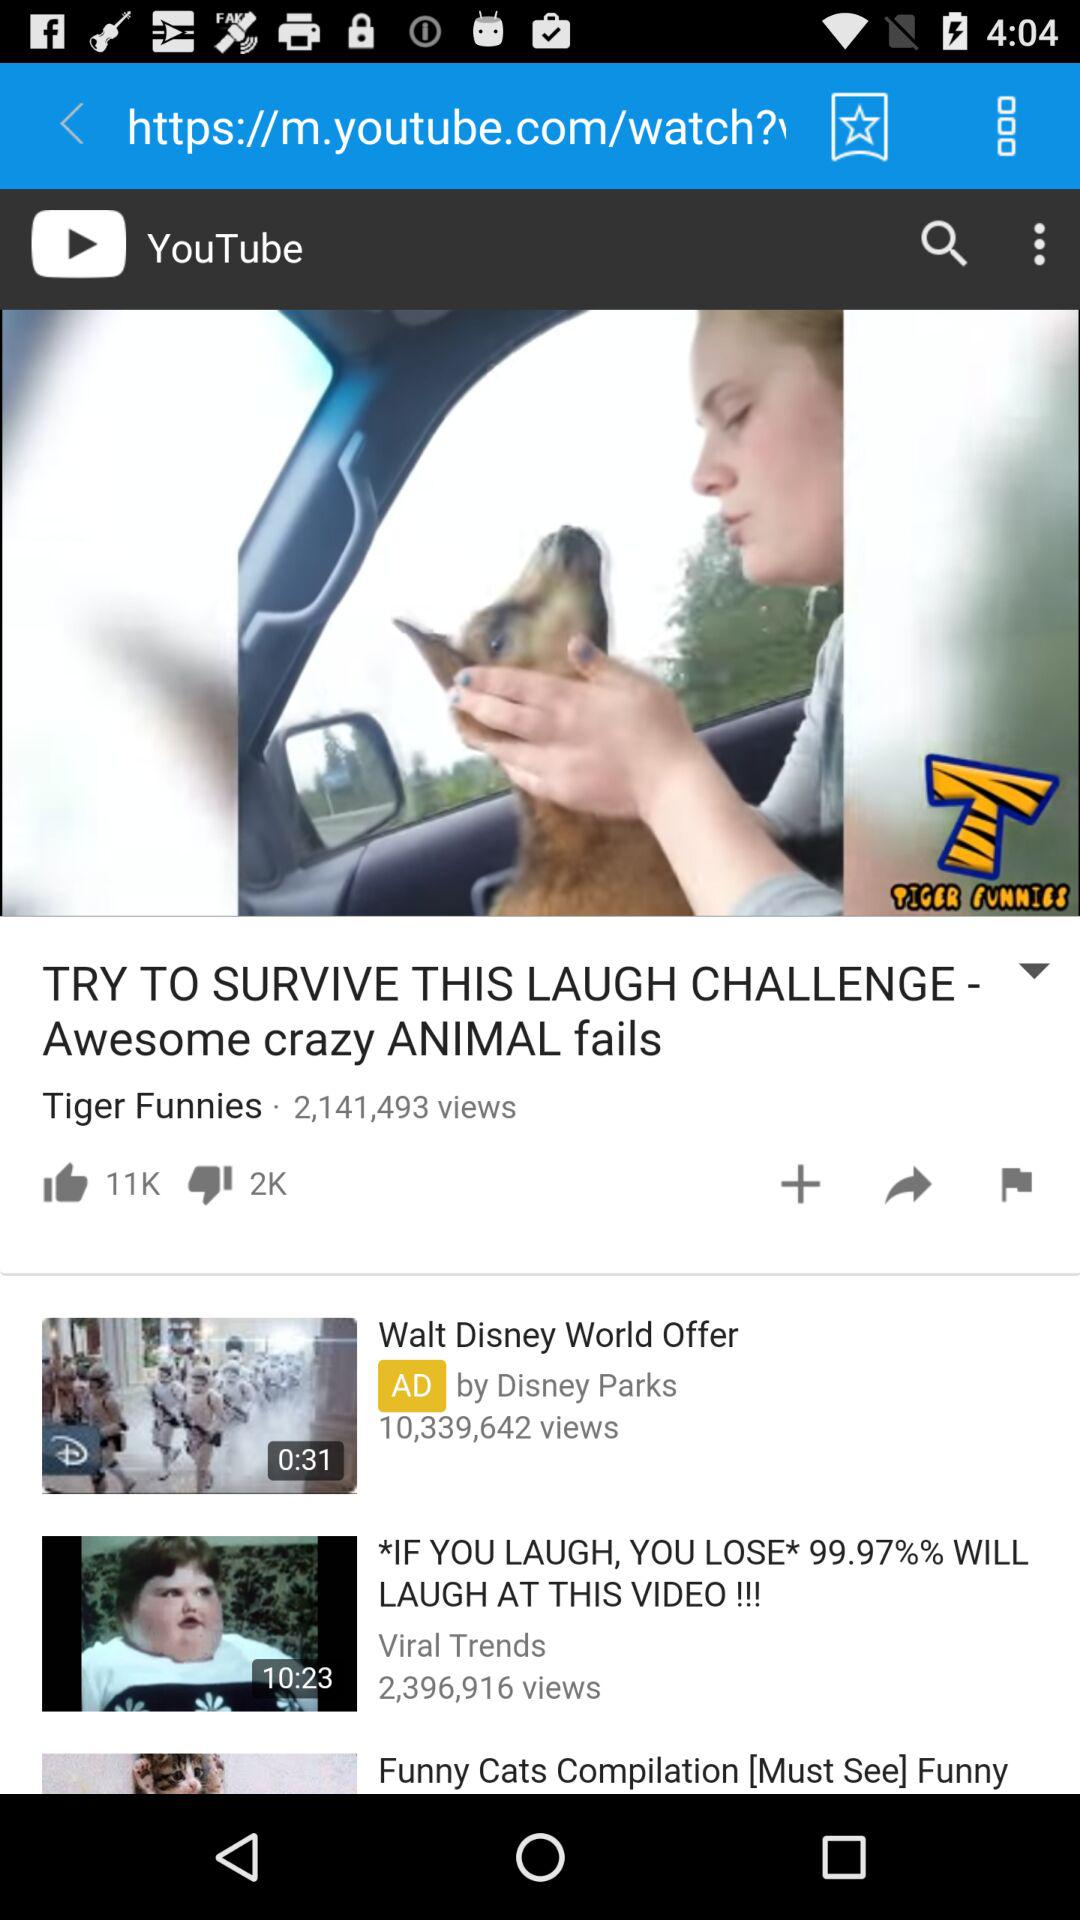How many people dislike the video "TRY TO SURVIVE THIS LAUGH CHALLENGE - Awesome crazy ANIMAL fails"? The video is disliked by 2K people. 